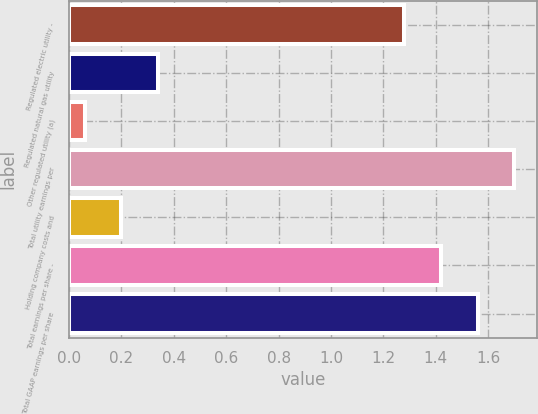<chart> <loc_0><loc_0><loc_500><loc_500><bar_chart><fcel>Regulated electric utility -<fcel>Regulated natural gas utility<fcel>Other regulated utility (a)<fcel>Total utility earnings per<fcel>Holding company costs and<fcel>Total earnings per share -<fcel>Total GAAP earnings per share<nl><fcel>1.28<fcel>0.34<fcel>0.06<fcel>1.7<fcel>0.2<fcel>1.42<fcel>1.56<nl></chart> 